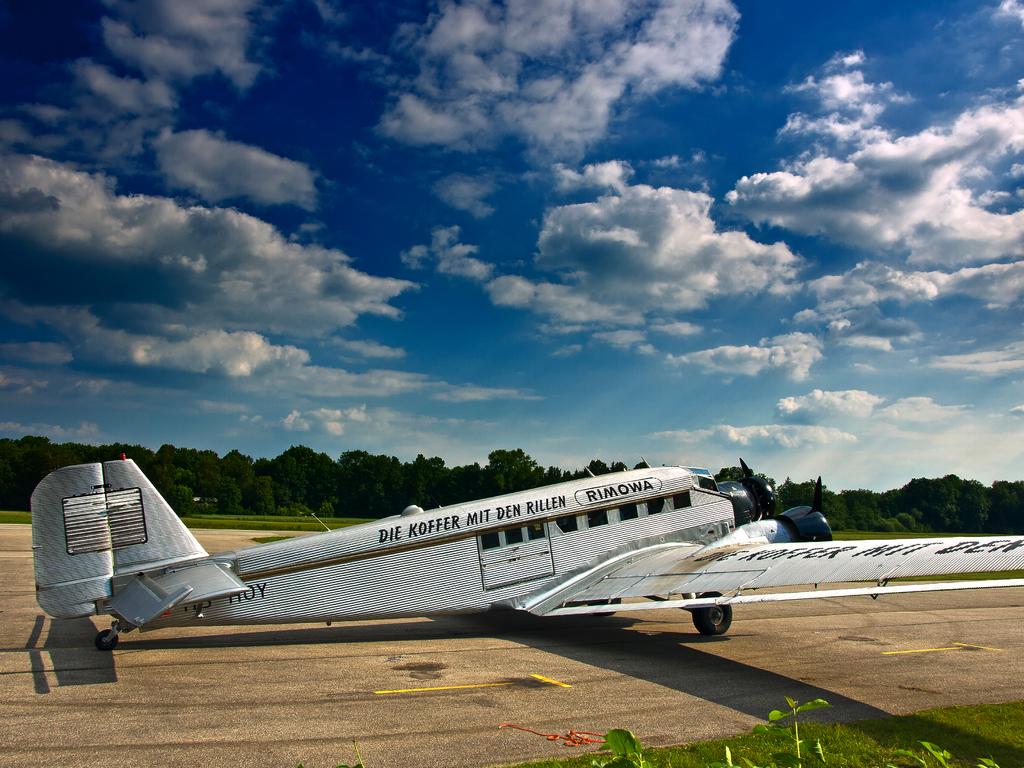What is the writing on the airplane?
Offer a terse response. Die koffer mit den rillen. Pie koffzzier plane?
Your answer should be compact. Unanswerable. 